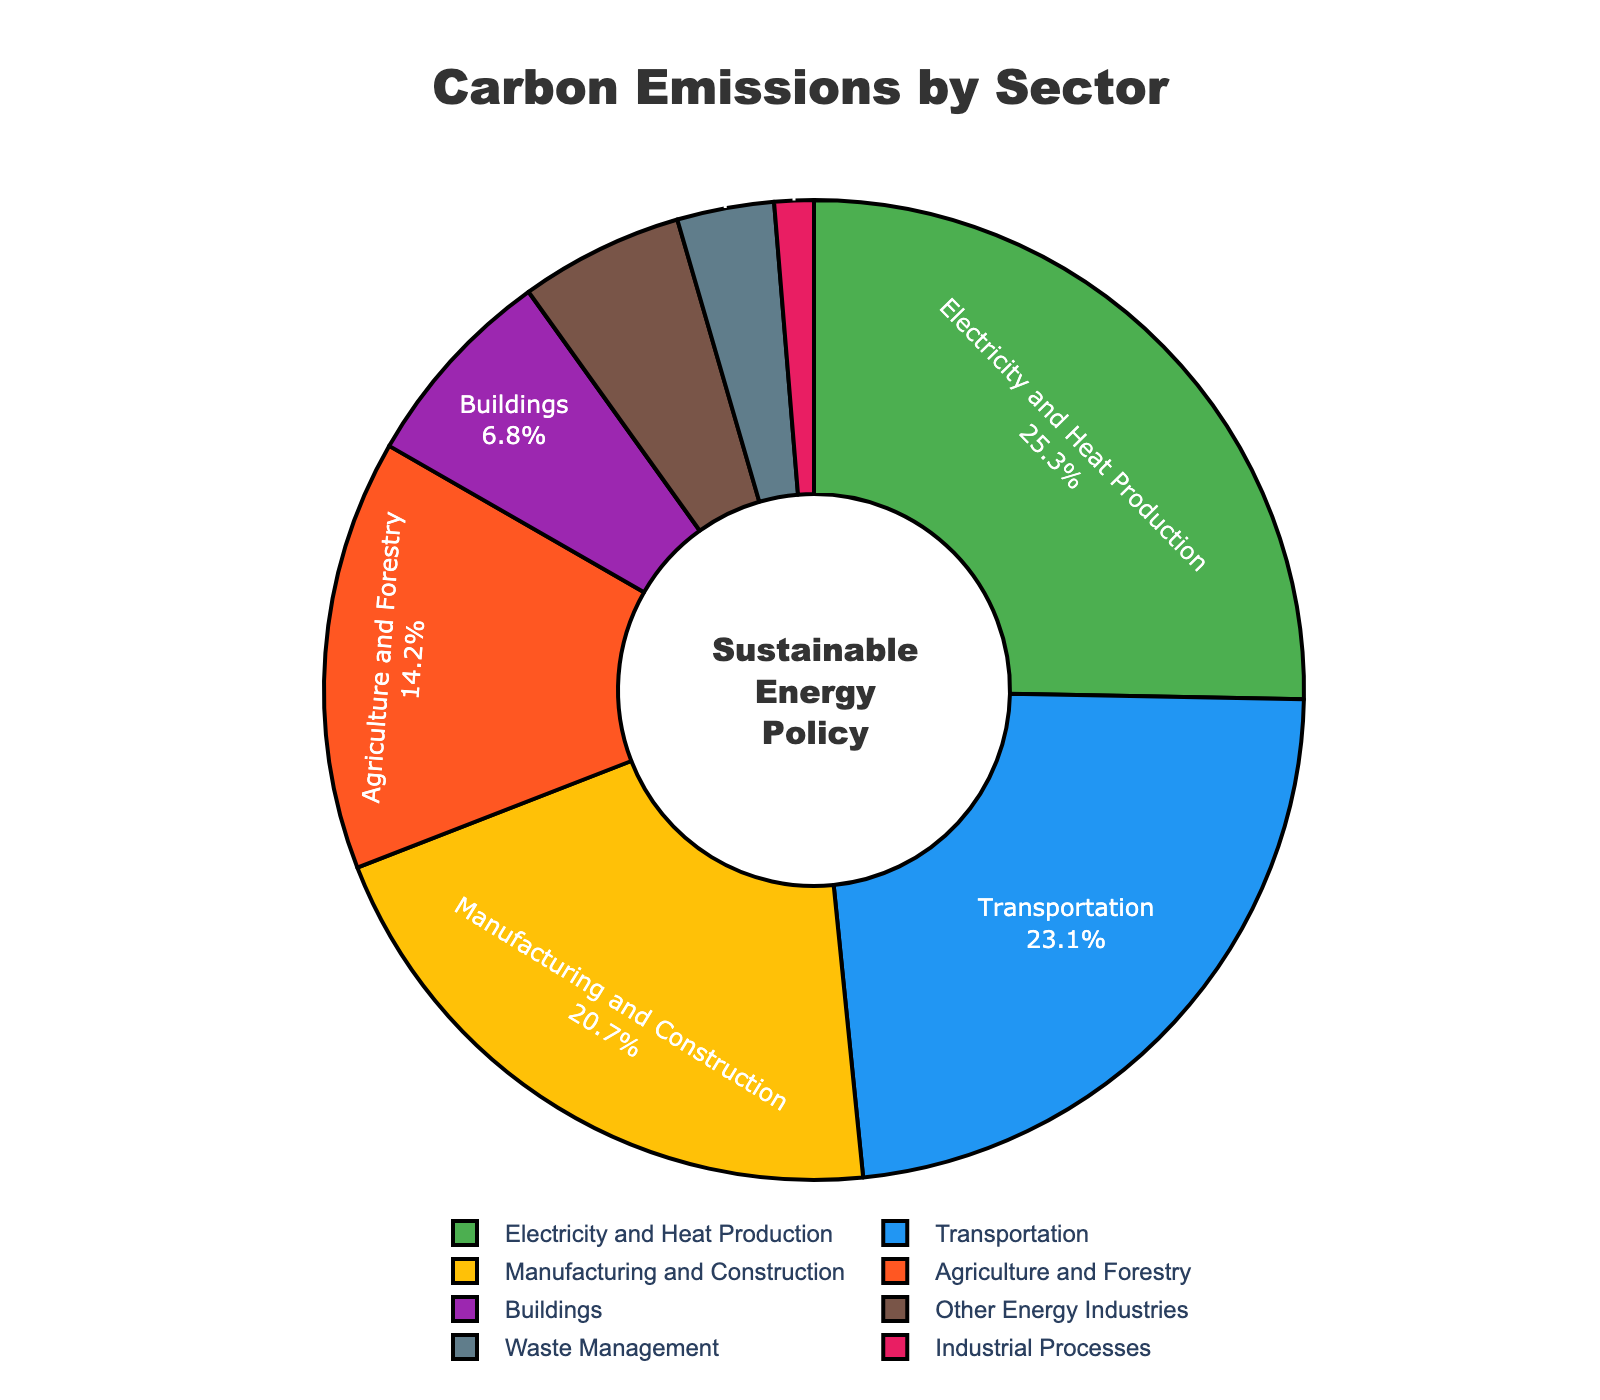what sector contributes the most to carbon emissions? The sector with the highest percentage of carbon emissions is the one that contributes the most. Looking at the pie chart, Electricity and Heat Production is the largest segment.
Answer: Electricity and Heat Production how much more does transportation contribute to carbon emissions compared to waste management? To find the difference between the contributions of Transportation and Waste Management, subtract the percentage of Waste Management from that of Transportation: 23.1% - 3.2% = 19.9%.
Answer: 19.9% what are the three largest contributors to carbon emissions? The three largest contributors can be determined by looking at the three largest segments of the pie chart. These are Electricity and Heat Production, Transportation, and Manufacturing and Construction.
Answer: Electricity and Heat Production, Transportation, Manufacturing and Construction what sectors combined contribute to over 50% of carbon emissions? To find sectors that together contribute more than 50%, sum their percentages until the total exceeds 50%. Electricity and Heat Production (25.3%) + Transportation (23.1%) equals 48.4%. Adding Manufacturing and Construction (20.7%) brings the total to 69.1%.
Answer: Electricity and Heat Production, Transportation, Manufacturing and Construction which sector has the smallest contribution to carbon emissions? The sector with the smallest percentage slice on the pie chart represents the smallest contribution. This is Industrial Processes with 1.3%.
Answer: Industrial Processes how much less does buildings sector contribute compared to manufacturing and construction? To find the difference, subtract the percentage of Buildings from that of Manufacturing and Construction: 20.7% - 6.8% = 13.9%.
Answer: 13.9% what color represents the agriculture and forestry sector? The color representing a specific sector can be observed directly on the pie chart. Agriculture and Forestry is represented by a section colored in purple.
Answer: Purple what percentage of carbon emissions is contributed by sectors other than electricity and heat production, transportation, and manufacturing and construction? Sum the percentages of the sectors other than the top three contributors: Agriculture and Forestry (14.2%), Buildings (6.8%), Other Energy Industries (5.4%), Waste Management (3.2%), Industrial Processes (1.3%). Adding these up gives 30.9%.
Answer: 30.9% by how much is waste management's contribution to carbon emissions greater than industrial processes? To find this, subtract the percentage of Industrial Processes from that of Waste Management: 3.2% - 1.3% = 1.9%.
Answer: 1.9% what text is displayed at the center of the pie chart's hole? The text displayed at the center can be seen directly in the visualization. It reads "Sustainable Energy Policy".
Answer: Sustainable Energy Policy 